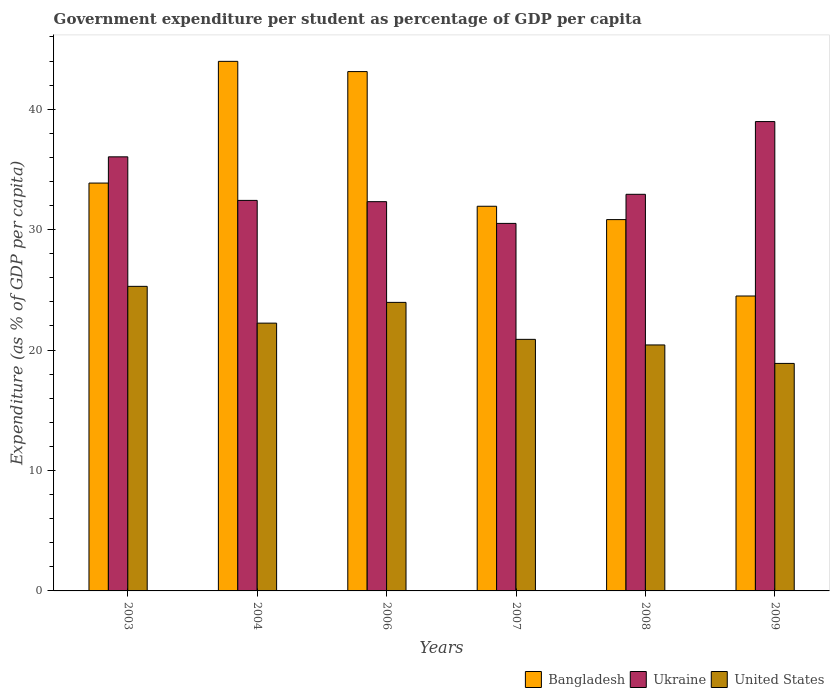How many different coloured bars are there?
Offer a terse response. 3. How many groups of bars are there?
Offer a terse response. 6. Are the number of bars per tick equal to the number of legend labels?
Offer a very short reply. Yes. Are the number of bars on each tick of the X-axis equal?
Your answer should be compact. Yes. What is the percentage of expenditure per student in United States in 2006?
Ensure brevity in your answer.  23.96. Across all years, what is the maximum percentage of expenditure per student in United States?
Give a very brief answer. 25.29. Across all years, what is the minimum percentage of expenditure per student in Bangladesh?
Keep it short and to the point. 24.49. In which year was the percentage of expenditure per student in Ukraine minimum?
Keep it short and to the point. 2007. What is the total percentage of expenditure per student in Bangladesh in the graph?
Provide a succinct answer. 208.23. What is the difference between the percentage of expenditure per student in United States in 2004 and that in 2007?
Provide a succinct answer. 1.35. What is the difference between the percentage of expenditure per student in Bangladesh in 2003 and the percentage of expenditure per student in Ukraine in 2009?
Provide a succinct answer. -5.11. What is the average percentage of expenditure per student in Ukraine per year?
Your answer should be very brief. 33.87. In the year 2003, what is the difference between the percentage of expenditure per student in United States and percentage of expenditure per student in Bangladesh?
Provide a short and direct response. -8.58. What is the ratio of the percentage of expenditure per student in Bangladesh in 2004 to that in 2006?
Provide a succinct answer. 1.02. Is the percentage of expenditure per student in Ukraine in 2004 less than that in 2007?
Your response must be concise. No. What is the difference between the highest and the second highest percentage of expenditure per student in United States?
Keep it short and to the point. 1.33. What is the difference between the highest and the lowest percentage of expenditure per student in Ukraine?
Your response must be concise. 8.46. In how many years, is the percentage of expenditure per student in Bangladesh greater than the average percentage of expenditure per student in Bangladesh taken over all years?
Offer a very short reply. 2. What does the 2nd bar from the left in 2007 represents?
Your answer should be compact. Ukraine. What does the 2nd bar from the right in 2003 represents?
Keep it short and to the point. Ukraine. Is it the case that in every year, the sum of the percentage of expenditure per student in Ukraine and percentage of expenditure per student in United States is greater than the percentage of expenditure per student in Bangladesh?
Give a very brief answer. Yes. How many bars are there?
Offer a very short reply. 18. Are all the bars in the graph horizontal?
Keep it short and to the point. No. Are the values on the major ticks of Y-axis written in scientific E-notation?
Keep it short and to the point. No. Does the graph contain any zero values?
Keep it short and to the point. No. Does the graph contain grids?
Keep it short and to the point. No. Where does the legend appear in the graph?
Offer a very short reply. Bottom right. How are the legend labels stacked?
Offer a terse response. Horizontal. What is the title of the graph?
Your response must be concise. Government expenditure per student as percentage of GDP per capita. What is the label or title of the Y-axis?
Make the answer very short. Expenditure (as % of GDP per capita). What is the Expenditure (as % of GDP per capita) of Bangladesh in 2003?
Provide a succinct answer. 33.87. What is the Expenditure (as % of GDP per capita) in Ukraine in 2003?
Give a very brief answer. 36.05. What is the Expenditure (as % of GDP per capita) of United States in 2003?
Offer a very short reply. 25.29. What is the Expenditure (as % of GDP per capita) in Bangladesh in 2004?
Make the answer very short. 43.97. What is the Expenditure (as % of GDP per capita) of Ukraine in 2004?
Give a very brief answer. 32.43. What is the Expenditure (as % of GDP per capita) in United States in 2004?
Ensure brevity in your answer.  22.24. What is the Expenditure (as % of GDP per capita) of Bangladesh in 2006?
Your answer should be compact. 43.12. What is the Expenditure (as % of GDP per capita) of Ukraine in 2006?
Offer a terse response. 32.32. What is the Expenditure (as % of GDP per capita) in United States in 2006?
Provide a short and direct response. 23.96. What is the Expenditure (as % of GDP per capita) in Bangladesh in 2007?
Your response must be concise. 31.94. What is the Expenditure (as % of GDP per capita) in Ukraine in 2007?
Offer a very short reply. 30.52. What is the Expenditure (as % of GDP per capita) in United States in 2007?
Make the answer very short. 20.89. What is the Expenditure (as % of GDP per capita) in Bangladesh in 2008?
Give a very brief answer. 30.83. What is the Expenditure (as % of GDP per capita) in Ukraine in 2008?
Make the answer very short. 32.93. What is the Expenditure (as % of GDP per capita) of United States in 2008?
Provide a succinct answer. 20.43. What is the Expenditure (as % of GDP per capita) of Bangladesh in 2009?
Ensure brevity in your answer.  24.49. What is the Expenditure (as % of GDP per capita) in Ukraine in 2009?
Ensure brevity in your answer.  38.97. What is the Expenditure (as % of GDP per capita) in United States in 2009?
Keep it short and to the point. 18.89. Across all years, what is the maximum Expenditure (as % of GDP per capita) of Bangladesh?
Provide a short and direct response. 43.97. Across all years, what is the maximum Expenditure (as % of GDP per capita) in Ukraine?
Ensure brevity in your answer.  38.97. Across all years, what is the maximum Expenditure (as % of GDP per capita) in United States?
Provide a succinct answer. 25.29. Across all years, what is the minimum Expenditure (as % of GDP per capita) of Bangladesh?
Provide a short and direct response. 24.49. Across all years, what is the minimum Expenditure (as % of GDP per capita) in Ukraine?
Ensure brevity in your answer.  30.52. Across all years, what is the minimum Expenditure (as % of GDP per capita) of United States?
Make the answer very short. 18.89. What is the total Expenditure (as % of GDP per capita) in Bangladesh in the graph?
Offer a very short reply. 208.23. What is the total Expenditure (as % of GDP per capita) in Ukraine in the graph?
Offer a very short reply. 203.22. What is the total Expenditure (as % of GDP per capita) of United States in the graph?
Provide a succinct answer. 131.69. What is the difference between the Expenditure (as % of GDP per capita) in Bangladesh in 2003 and that in 2004?
Keep it short and to the point. -10.11. What is the difference between the Expenditure (as % of GDP per capita) in Ukraine in 2003 and that in 2004?
Make the answer very short. 3.62. What is the difference between the Expenditure (as % of GDP per capita) in United States in 2003 and that in 2004?
Make the answer very short. 3.05. What is the difference between the Expenditure (as % of GDP per capita) of Bangladesh in 2003 and that in 2006?
Your answer should be compact. -9.26. What is the difference between the Expenditure (as % of GDP per capita) of Ukraine in 2003 and that in 2006?
Your response must be concise. 3.72. What is the difference between the Expenditure (as % of GDP per capita) of United States in 2003 and that in 2006?
Offer a very short reply. 1.33. What is the difference between the Expenditure (as % of GDP per capita) in Bangladesh in 2003 and that in 2007?
Offer a terse response. 1.93. What is the difference between the Expenditure (as % of GDP per capita) of Ukraine in 2003 and that in 2007?
Offer a terse response. 5.53. What is the difference between the Expenditure (as % of GDP per capita) in United States in 2003 and that in 2007?
Keep it short and to the point. 4.4. What is the difference between the Expenditure (as % of GDP per capita) of Bangladesh in 2003 and that in 2008?
Your answer should be very brief. 3.03. What is the difference between the Expenditure (as % of GDP per capita) of Ukraine in 2003 and that in 2008?
Your answer should be compact. 3.11. What is the difference between the Expenditure (as % of GDP per capita) of United States in 2003 and that in 2008?
Offer a terse response. 4.87. What is the difference between the Expenditure (as % of GDP per capita) in Bangladesh in 2003 and that in 2009?
Offer a terse response. 9.38. What is the difference between the Expenditure (as % of GDP per capita) in Ukraine in 2003 and that in 2009?
Ensure brevity in your answer.  -2.93. What is the difference between the Expenditure (as % of GDP per capita) of United States in 2003 and that in 2009?
Your response must be concise. 6.4. What is the difference between the Expenditure (as % of GDP per capita) of Bangladesh in 2004 and that in 2006?
Give a very brief answer. 0.85. What is the difference between the Expenditure (as % of GDP per capita) in Ukraine in 2004 and that in 2006?
Give a very brief answer. 0.11. What is the difference between the Expenditure (as % of GDP per capita) in United States in 2004 and that in 2006?
Your answer should be very brief. -1.72. What is the difference between the Expenditure (as % of GDP per capita) in Bangladesh in 2004 and that in 2007?
Give a very brief answer. 12.03. What is the difference between the Expenditure (as % of GDP per capita) of Ukraine in 2004 and that in 2007?
Your answer should be very brief. 1.91. What is the difference between the Expenditure (as % of GDP per capita) of United States in 2004 and that in 2007?
Provide a succinct answer. 1.35. What is the difference between the Expenditure (as % of GDP per capita) of Bangladesh in 2004 and that in 2008?
Offer a very short reply. 13.14. What is the difference between the Expenditure (as % of GDP per capita) in Ukraine in 2004 and that in 2008?
Make the answer very short. -0.51. What is the difference between the Expenditure (as % of GDP per capita) of United States in 2004 and that in 2008?
Provide a succinct answer. 1.81. What is the difference between the Expenditure (as % of GDP per capita) of Bangladesh in 2004 and that in 2009?
Your answer should be very brief. 19.48. What is the difference between the Expenditure (as % of GDP per capita) in Ukraine in 2004 and that in 2009?
Make the answer very short. -6.55. What is the difference between the Expenditure (as % of GDP per capita) in United States in 2004 and that in 2009?
Your answer should be compact. 3.34. What is the difference between the Expenditure (as % of GDP per capita) of Bangladesh in 2006 and that in 2007?
Give a very brief answer. 11.18. What is the difference between the Expenditure (as % of GDP per capita) of Ukraine in 2006 and that in 2007?
Make the answer very short. 1.8. What is the difference between the Expenditure (as % of GDP per capita) in United States in 2006 and that in 2007?
Your answer should be very brief. 3.07. What is the difference between the Expenditure (as % of GDP per capita) of Bangladesh in 2006 and that in 2008?
Your answer should be compact. 12.29. What is the difference between the Expenditure (as % of GDP per capita) of Ukraine in 2006 and that in 2008?
Offer a very short reply. -0.61. What is the difference between the Expenditure (as % of GDP per capita) in United States in 2006 and that in 2008?
Keep it short and to the point. 3.53. What is the difference between the Expenditure (as % of GDP per capita) of Bangladesh in 2006 and that in 2009?
Your answer should be very brief. 18.64. What is the difference between the Expenditure (as % of GDP per capita) of Ukraine in 2006 and that in 2009?
Your response must be concise. -6.65. What is the difference between the Expenditure (as % of GDP per capita) of United States in 2006 and that in 2009?
Make the answer very short. 5.07. What is the difference between the Expenditure (as % of GDP per capita) of Bangladesh in 2007 and that in 2008?
Keep it short and to the point. 1.11. What is the difference between the Expenditure (as % of GDP per capita) of Ukraine in 2007 and that in 2008?
Ensure brevity in your answer.  -2.42. What is the difference between the Expenditure (as % of GDP per capita) of United States in 2007 and that in 2008?
Your response must be concise. 0.46. What is the difference between the Expenditure (as % of GDP per capita) in Bangladesh in 2007 and that in 2009?
Your response must be concise. 7.45. What is the difference between the Expenditure (as % of GDP per capita) in Ukraine in 2007 and that in 2009?
Your response must be concise. -8.46. What is the difference between the Expenditure (as % of GDP per capita) of United States in 2007 and that in 2009?
Provide a short and direct response. 2. What is the difference between the Expenditure (as % of GDP per capita) of Bangladesh in 2008 and that in 2009?
Keep it short and to the point. 6.34. What is the difference between the Expenditure (as % of GDP per capita) of Ukraine in 2008 and that in 2009?
Your response must be concise. -6.04. What is the difference between the Expenditure (as % of GDP per capita) in United States in 2008 and that in 2009?
Provide a succinct answer. 1.53. What is the difference between the Expenditure (as % of GDP per capita) in Bangladesh in 2003 and the Expenditure (as % of GDP per capita) in Ukraine in 2004?
Ensure brevity in your answer.  1.44. What is the difference between the Expenditure (as % of GDP per capita) of Bangladesh in 2003 and the Expenditure (as % of GDP per capita) of United States in 2004?
Offer a very short reply. 11.63. What is the difference between the Expenditure (as % of GDP per capita) in Ukraine in 2003 and the Expenditure (as % of GDP per capita) in United States in 2004?
Your answer should be compact. 13.81. What is the difference between the Expenditure (as % of GDP per capita) of Bangladesh in 2003 and the Expenditure (as % of GDP per capita) of Ukraine in 2006?
Make the answer very short. 1.54. What is the difference between the Expenditure (as % of GDP per capita) of Bangladesh in 2003 and the Expenditure (as % of GDP per capita) of United States in 2006?
Offer a terse response. 9.91. What is the difference between the Expenditure (as % of GDP per capita) in Ukraine in 2003 and the Expenditure (as % of GDP per capita) in United States in 2006?
Provide a short and direct response. 12.09. What is the difference between the Expenditure (as % of GDP per capita) in Bangladesh in 2003 and the Expenditure (as % of GDP per capita) in Ukraine in 2007?
Ensure brevity in your answer.  3.35. What is the difference between the Expenditure (as % of GDP per capita) in Bangladesh in 2003 and the Expenditure (as % of GDP per capita) in United States in 2007?
Provide a succinct answer. 12.98. What is the difference between the Expenditure (as % of GDP per capita) of Ukraine in 2003 and the Expenditure (as % of GDP per capita) of United States in 2007?
Keep it short and to the point. 15.16. What is the difference between the Expenditure (as % of GDP per capita) in Bangladesh in 2003 and the Expenditure (as % of GDP per capita) in Ukraine in 2008?
Offer a terse response. 0.93. What is the difference between the Expenditure (as % of GDP per capita) in Bangladesh in 2003 and the Expenditure (as % of GDP per capita) in United States in 2008?
Provide a succinct answer. 13.44. What is the difference between the Expenditure (as % of GDP per capita) of Ukraine in 2003 and the Expenditure (as % of GDP per capita) of United States in 2008?
Your answer should be compact. 15.62. What is the difference between the Expenditure (as % of GDP per capita) in Bangladesh in 2003 and the Expenditure (as % of GDP per capita) in Ukraine in 2009?
Ensure brevity in your answer.  -5.11. What is the difference between the Expenditure (as % of GDP per capita) of Bangladesh in 2003 and the Expenditure (as % of GDP per capita) of United States in 2009?
Offer a terse response. 14.98. What is the difference between the Expenditure (as % of GDP per capita) of Ukraine in 2003 and the Expenditure (as % of GDP per capita) of United States in 2009?
Your answer should be compact. 17.15. What is the difference between the Expenditure (as % of GDP per capita) of Bangladesh in 2004 and the Expenditure (as % of GDP per capita) of Ukraine in 2006?
Provide a short and direct response. 11.65. What is the difference between the Expenditure (as % of GDP per capita) in Bangladesh in 2004 and the Expenditure (as % of GDP per capita) in United States in 2006?
Ensure brevity in your answer.  20.01. What is the difference between the Expenditure (as % of GDP per capita) of Ukraine in 2004 and the Expenditure (as % of GDP per capita) of United States in 2006?
Your answer should be compact. 8.47. What is the difference between the Expenditure (as % of GDP per capita) of Bangladesh in 2004 and the Expenditure (as % of GDP per capita) of Ukraine in 2007?
Your response must be concise. 13.46. What is the difference between the Expenditure (as % of GDP per capita) of Bangladesh in 2004 and the Expenditure (as % of GDP per capita) of United States in 2007?
Offer a terse response. 23.08. What is the difference between the Expenditure (as % of GDP per capita) of Ukraine in 2004 and the Expenditure (as % of GDP per capita) of United States in 2007?
Keep it short and to the point. 11.54. What is the difference between the Expenditure (as % of GDP per capita) in Bangladesh in 2004 and the Expenditure (as % of GDP per capita) in Ukraine in 2008?
Ensure brevity in your answer.  11.04. What is the difference between the Expenditure (as % of GDP per capita) in Bangladesh in 2004 and the Expenditure (as % of GDP per capita) in United States in 2008?
Your answer should be compact. 23.55. What is the difference between the Expenditure (as % of GDP per capita) in Ukraine in 2004 and the Expenditure (as % of GDP per capita) in United States in 2008?
Provide a short and direct response. 12. What is the difference between the Expenditure (as % of GDP per capita) of Bangladesh in 2004 and the Expenditure (as % of GDP per capita) of Ukraine in 2009?
Ensure brevity in your answer.  5. What is the difference between the Expenditure (as % of GDP per capita) in Bangladesh in 2004 and the Expenditure (as % of GDP per capita) in United States in 2009?
Your answer should be very brief. 25.08. What is the difference between the Expenditure (as % of GDP per capita) of Ukraine in 2004 and the Expenditure (as % of GDP per capita) of United States in 2009?
Give a very brief answer. 13.54. What is the difference between the Expenditure (as % of GDP per capita) in Bangladesh in 2006 and the Expenditure (as % of GDP per capita) in Ukraine in 2007?
Your response must be concise. 12.61. What is the difference between the Expenditure (as % of GDP per capita) of Bangladesh in 2006 and the Expenditure (as % of GDP per capita) of United States in 2007?
Your response must be concise. 22.23. What is the difference between the Expenditure (as % of GDP per capita) of Ukraine in 2006 and the Expenditure (as % of GDP per capita) of United States in 2007?
Provide a succinct answer. 11.43. What is the difference between the Expenditure (as % of GDP per capita) in Bangladesh in 2006 and the Expenditure (as % of GDP per capita) in Ukraine in 2008?
Ensure brevity in your answer.  10.19. What is the difference between the Expenditure (as % of GDP per capita) in Bangladesh in 2006 and the Expenditure (as % of GDP per capita) in United States in 2008?
Your answer should be very brief. 22.7. What is the difference between the Expenditure (as % of GDP per capita) in Ukraine in 2006 and the Expenditure (as % of GDP per capita) in United States in 2008?
Ensure brevity in your answer.  11.9. What is the difference between the Expenditure (as % of GDP per capita) of Bangladesh in 2006 and the Expenditure (as % of GDP per capita) of Ukraine in 2009?
Provide a short and direct response. 4.15. What is the difference between the Expenditure (as % of GDP per capita) of Bangladesh in 2006 and the Expenditure (as % of GDP per capita) of United States in 2009?
Keep it short and to the point. 24.23. What is the difference between the Expenditure (as % of GDP per capita) in Ukraine in 2006 and the Expenditure (as % of GDP per capita) in United States in 2009?
Ensure brevity in your answer.  13.43. What is the difference between the Expenditure (as % of GDP per capita) in Bangladesh in 2007 and the Expenditure (as % of GDP per capita) in Ukraine in 2008?
Provide a short and direct response. -0.99. What is the difference between the Expenditure (as % of GDP per capita) in Bangladesh in 2007 and the Expenditure (as % of GDP per capita) in United States in 2008?
Provide a succinct answer. 11.52. What is the difference between the Expenditure (as % of GDP per capita) in Ukraine in 2007 and the Expenditure (as % of GDP per capita) in United States in 2008?
Make the answer very short. 10.09. What is the difference between the Expenditure (as % of GDP per capita) of Bangladesh in 2007 and the Expenditure (as % of GDP per capita) of Ukraine in 2009?
Your answer should be compact. -7.03. What is the difference between the Expenditure (as % of GDP per capita) of Bangladesh in 2007 and the Expenditure (as % of GDP per capita) of United States in 2009?
Make the answer very short. 13.05. What is the difference between the Expenditure (as % of GDP per capita) of Ukraine in 2007 and the Expenditure (as % of GDP per capita) of United States in 2009?
Offer a terse response. 11.63. What is the difference between the Expenditure (as % of GDP per capita) of Bangladesh in 2008 and the Expenditure (as % of GDP per capita) of Ukraine in 2009?
Give a very brief answer. -8.14. What is the difference between the Expenditure (as % of GDP per capita) in Bangladesh in 2008 and the Expenditure (as % of GDP per capita) in United States in 2009?
Make the answer very short. 11.94. What is the difference between the Expenditure (as % of GDP per capita) of Ukraine in 2008 and the Expenditure (as % of GDP per capita) of United States in 2009?
Your answer should be compact. 14.04. What is the average Expenditure (as % of GDP per capita) of Bangladesh per year?
Make the answer very short. 34.7. What is the average Expenditure (as % of GDP per capita) of Ukraine per year?
Provide a succinct answer. 33.87. What is the average Expenditure (as % of GDP per capita) of United States per year?
Provide a succinct answer. 21.95. In the year 2003, what is the difference between the Expenditure (as % of GDP per capita) in Bangladesh and Expenditure (as % of GDP per capita) in Ukraine?
Keep it short and to the point. -2.18. In the year 2003, what is the difference between the Expenditure (as % of GDP per capita) in Bangladesh and Expenditure (as % of GDP per capita) in United States?
Ensure brevity in your answer.  8.58. In the year 2003, what is the difference between the Expenditure (as % of GDP per capita) in Ukraine and Expenditure (as % of GDP per capita) in United States?
Ensure brevity in your answer.  10.75. In the year 2004, what is the difference between the Expenditure (as % of GDP per capita) of Bangladesh and Expenditure (as % of GDP per capita) of Ukraine?
Give a very brief answer. 11.55. In the year 2004, what is the difference between the Expenditure (as % of GDP per capita) of Bangladesh and Expenditure (as % of GDP per capita) of United States?
Your answer should be compact. 21.74. In the year 2004, what is the difference between the Expenditure (as % of GDP per capita) of Ukraine and Expenditure (as % of GDP per capita) of United States?
Keep it short and to the point. 10.19. In the year 2006, what is the difference between the Expenditure (as % of GDP per capita) of Bangladesh and Expenditure (as % of GDP per capita) of Ukraine?
Ensure brevity in your answer.  10.8. In the year 2006, what is the difference between the Expenditure (as % of GDP per capita) in Bangladesh and Expenditure (as % of GDP per capita) in United States?
Provide a short and direct response. 19.16. In the year 2006, what is the difference between the Expenditure (as % of GDP per capita) in Ukraine and Expenditure (as % of GDP per capita) in United States?
Provide a short and direct response. 8.36. In the year 2007, what is the difference between the Expenditure (as % of GDP per capita) of Bangladesh and Expenditure (as % of GDP per capita) of Ukraine?
Ensure brevity in your answer.  1.42. In the year 2007, what is the difference between the Expenditure (as % of GDP per capita) in Bangladesh and Expenditure (as % of GDP per capita) in United States?
Give a very brief answer. 11.05. In the year 2007, what is the difference between the Expenditure (as % of GDP per capita) of Ukraine and Expenditure (as % of GDP per capita) of United States?
Offer a terse response. 9.63. In the year 2008, what is the difference between the Expenditure (as % of GDP per capita) in Bangladesh and Expenditure (as % of GDP per capita) in Ukraine?
Offer a very short reply. -2.1. In the year 2008, what is the difference between the Expenditure (as % of GDP per capita) of Bangladesh and Expenditure (as % of GDP per capita) of United States?
Provide a succinct answer. 10.41. In the year 2008, what is the difference between the Expenditure (as % of GDP per capita) of Ukraine and Expenditure (as % of GDP per capita) of United States?
Your answer should be very brief. 12.51. In the year 2009, what is the difference between the Expenditure (as % of GDP per capita) in Bangladesh and Expenditure (as % of GDP per capita) in Ukraine?
Offer a very short reply. -14.48. In the year 2009, what is the difference between the Expenditure (as % of GDP per capita) in Bangladesh and Expenditure (as % of GDP per capita) in United States?
Provide a succinct answer. 5.6. In the year 2009, what is the difference between the Expenditure (as % of GDP per capita) in Ukraine and Expenditure (as % of GDP per capita) in United States?
Keep it short and to the point. 20.08. What is the ratio of the Expenditure (as % of GDP per capita) of Bangladesh in 2003 to that in 2004?
Provide a succinct answer. 0.77. What is the ratio of the Expenditure (as % of GDP per capita) of Ukraine in 2003 to that in 2004?
Ensure brevity in your answer.  1.11. What is the ratio of the Expenditure (as % of GDP per capita) of United States in 2003 to that in 2004?
Your response must be concise. 1.14. What is the ratio of the Expenditure (as % of GDP per capita) of Bangladesh in 2003 to that in 2006?
Ensure brevity in your answer.  0.79. What is the ratio of the Expenditure (as % of GDP per capita) of Ukraine in 2003 to that in 2006?
Your response must be concise. 1.12. What is the ratio of the Expenditure (as % of GDP per capita) of United States in 2003 to that in 2006?
Keep it short and to the point. 1.06. What is the ratio of the Expenditure (as % of GDP per capita) of Bangladesh in 2003 to that in 2007?
Keep it short and to the point. 1.06. What is the ratio of the Expenditure (as % of GDP per capita) of Ukraine in 2003 to that in 2007?
Your answer should be compact. 1.18. What is the ratio of the Expenditure (as % of GDP per capita) in United States in 2003 to that in 2007?
Provide a short and direct response. 1.21. What is the ratio of the Expenditure (as % of GDP per capita) of Bangladesh in 2003 to that in 2008?
Your response must be concise. 1.1. What is the ratio of the Expenditure (as % of GDP per capita) of Ukraine in 2003 to that in 2008?
Offer a terse response. 1.09. What is the ratio of the Expenditure (as % of GDP per capita) in United States in 2003 to that in 2008?
Your answer should be compact. 1.24. What is the ratio of the Expenditure (as % of GDP per capita) of Bangladesh in 2003 to that in 2009?
Ensure brevity in your answer.  1.38. What is the ratio of the Expenditure (as % of GDP per capita) of Ukraine in 2003 to that in 2009?
Give a very brief answer. 0.92. What is the ratio of the Expenditure (as % of GDP per capita) in United States in 2003 to that in 2009?
Offer a very short reply. 1.34. What is the ratio of the Expenditure (as % of GDP per capita) of Bangladesh in 2004 to that in 2006?
Give a very brief answer. 1.02. What is the ratio of the Expenditure (as % of GDP per capita) of United States in 2004 to that in 2006?
Your response must be concise. 0.93. What is the ratio of the Expenditure (as % of GDP per capita) in Bangladesh in 2004 to that in 2007?
Make the answer very short. 1.38. What is the ratio of the Expenditure (as % of GDP per capita) of Ukraine in 2004 to that in 2007?
Offer a very short reply. 1.06. What is the ratio of the Expenditure (as % of GDP per capita) of United States in 2004 to that in 2007?
Your response must be concise. 1.06. What is the ratio of the Expenditure (as % of GDP per capita) of Bangladesh in 2004 to that in 2008?
Offer a very short reply. 1.43. What is the ratio of the Expenditure (as % of GDP per capita) of Ukraine in 2004 to that in 2008?
Give a very brief answer. 0.98. What is the ratio of the Expenditure (as % of GDP per capita) of United States in 2004 to that in 2008?
Your answer should be very brief. 1.09. What is the ratio of the Expenditure (as % of GDP per capita) of Bangladesh in 2004 to that in 2009?
Your response must be concise. 1.8. What is the ratio of the Expenditure (as % of GDP per capita) in Ukraine in 2004 to that in 2009?
Give a very brief answer. 0.83. What is the ratio of the Expenditure (as % of GDP per capita) in United States in 2004 to that in 2009?
Offer a terse response. 1.18. What is the ratio of the Expenditure (as % of GDP per capita) in Bangladesh in 2006 to that in 2007?
Provide a short and direct response. 1.35. What is the ratio of the Expenditure (as % of GDP per capita) of Ukraine in 2006 to that in 2007?
Keep it short and to the point. 1.06. What is the ratio of the Expenditure (as % of GDP per capita) of United States in 2006 to that in 2007?
Your answer should be compact. 1.15. What is the ratio of the Expenditure (as % of GDP per capita) in Bangladesh in 2006 to that in 2008?
Your answer should be compact. 1.4. What is the ratio of the Expenditure (as % of GDP per capita) in Ukraine in 2006 to that in 2008?
Ensure brevity in your answer.  0.98. What is the ratio of the Expenditure (as % of GDP per capita) in United States in 2006 to that in 2008?
Make the answer very short. 1.17. What is the ratio of the Expenditure (as % of GDP per capita) of Bangladesh in 2006 to that in 2009?
Your response must be concise. 1.76. What is the ratio of the Expenditure (as % of GDP per capita) of Ukraine in 2006 to that in 2009?
Make the answer very short. 0.83. What is the ratio of the Expenditure (as % of GDP per capita) of United States in 2006 to that in 2009?
Your answer should be very brief. 1.27. What is the ratio of the Expenditure (as % of GDP per capita) of Bangladesh in 2007 to that in 2008?
Give a very brief answer. 1.04. What is the ratio of the Expenditure (as % of GDP per capita) in Ukraine in 2007 to that in 2008?
Keep it short and to the point. 0.93. What is the ratio of the Expenditure (as % of GDP per capita) in United States in 2007 to that in 2008?
Give a very brief answer. 1.02. What is the ratio of the Expenditure (as % of GDP per capita) of Bangladesh in 2007 to that in 2009?
Keep it short and to the point. 1.3. What is the ratio of the Expenditure (as % of GDP per capita) of Ukraine in 2007 to that in 2009?
Give a very brief answer. 0.78. What is the ratio of the Expenditure (as % of GDP per capita) of United States in 2007 to that in 2009?
Your response must be concise. 1.11. What is the ratio of the Expenditure (as % of GDP per capita) of Bangladesh in 2008 to that in 2009?
Ensure brevity in your answer.  1.26. What is the ratio of the Expenditure (as % of GDP per capita) in Ukraine in 2008 to that in 2009?
Your answer should be compact. 0.84. What is the ratio of the Expenditure (as % of GDP per capita) of United States in 2008 to that in 2009?
Make the answer very short. 1.08. What is the difference between the highest and the second highest Expenditure (as % of GDP per capita) of Bangladesh?
Your answer should be compact. 0.85. What is the difference between the highest and the second highest Expenditure (as % of GDP per capita) in Ukraine?
Your answer should be very brief. 2.93. What is the difference between the highest and the second highest Expenditure (as % of GDP per capita) in United States?
Provide a succinct answer. 1.33. What is the difference between the highest and the lowest Expenditure (as % of GDP per capita) of Bangladesh?
Your answer should be compact. 19.48. What is the difference between the highest and the lowest Expenditure (as % of GDP per capita) of Ukraine?
Ensure brevity in your answer.  8.46. What is the difference between the highest and the lowest Expenditure (as % of GDP per capita) of United States?
Your answer should be compact. 6.4. 